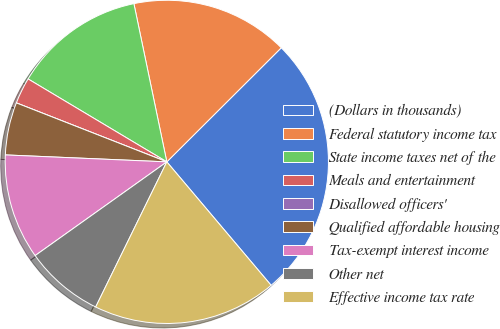<chart> <loc_0><loc_0><loc_500><loc_500><pie_chart><fcel>(Dollars in thousands)<fcel>Federal statutory income tax<fcel>State income taxes net of the<fcel>Meals and entertainment<fcel>Disallowed officers'<fcel>Qualified affordable housing<fcel>Tax-exempt interest income<fcel>Other net<fcel>Effective income tax rate<nl><fcel>26.31%<fcel>15.79%<fcel>13.16%<fcel>2.63%<fcel>0.0%<fcel>5.26%<fcel>10.53%<fcel>7.9%<fcel>18.42%<nl></chart> 